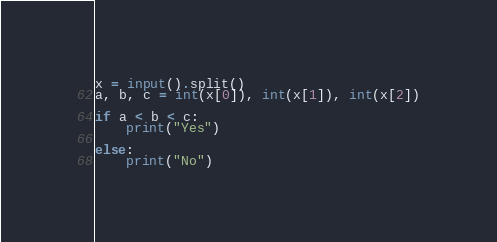<code> <loc_0><loc_0><loc_500><loc_500><_Python_>x = input().split()
a, b, c = int(x[0]), int(x[1]), int(x[2])

if a < b < c:
    print("Yes")

else:
    print("No")
</code> 